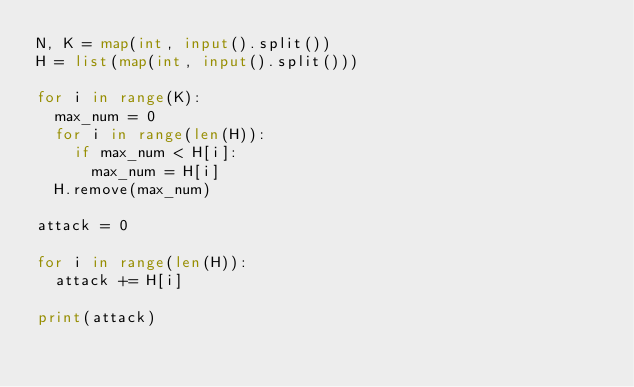<code> <loc_0><loc_0><loc_500><loc_500><_Python_>N, K = map(int, input().split())
H = list(map(int, input().split()))

for i in range(K):
  max_num = 0
  for i in range(len(H)):
    if max_num < H[i]:
      max_num = H[i]
  H.remove(max_num)

attack = 0

for i in range(len(H)):
  attack += H[i]
  
print(attack)</code> 